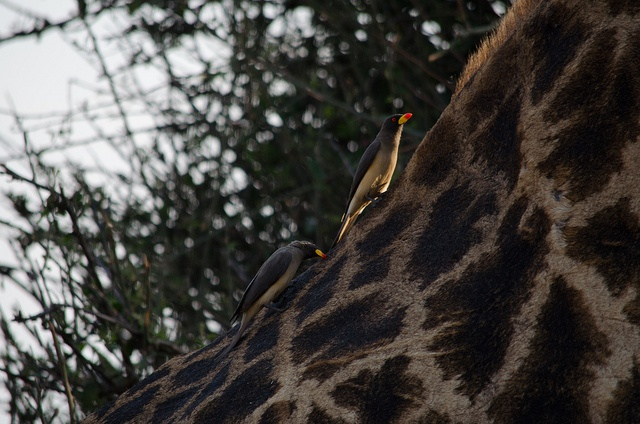Describe the objects in this image and their specific colors. I can see giraffe in lightgray, black, gray, and maroon tones, bird in lightgray, black, and gray tones, and bird in lightgray, black, maroon, and gray tones in this image. 